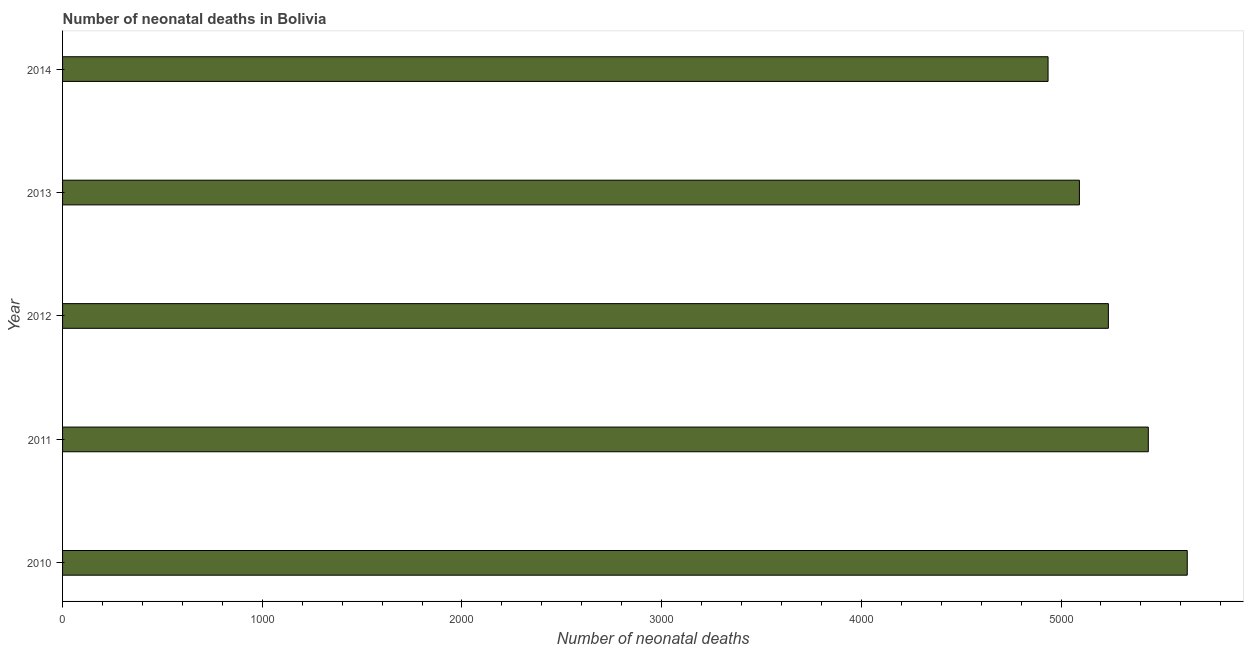Does the graph contain any zero values?
Ensure brevity in your answer.  No. What is the title of the graph?
Provide a succinct answer. Number of neonatal deaths in Bolivia. What is the label or title of the X-axis?
Offer a terse response. Number of neonatal deaths. What is the label or title of the Y-axis?
Make the answer very short. Year. What is the number of neonatal deaths in 2011?
Keep it short and to the point. 5437. Across all years, what is the maximum number of neonatal deaths?
Give a very brief answer. 5632. Across all years, what is the minimum number of neonatal deaths?
Offer a terse response. 4935. In which year was the number of neonatal deaths maximum?
Keep it short and to the point. 2010. In which year was the number of neonatal deaths minimum?
Ensure brevity in your answer.  2014. What is the sum of the number of neonatal deaths?
Provide a succinct answer. 2.63e+04. What is the difference between the number of neonatal deaths in 2013 and 2014?
Offer a very short reply. 157. What is the average number of neonatal deaths per year?
Make the answer very short. 5266. What is the median number of neonatal deaths?
Your answer should be very brief. 5237. What is the ratio of the number of neonatal deaths in 2010 to that in 2012?
Ensure brevity in your answer.  1.07. Is the difference between the number of neonatal deaths in 2013 and 2014 greater than the difference between any two years?
Your answer should be compact. No. What is the difference between the highest and the second highest number of neonatal deaths?
Provide a short and direct response. 195. Is the sum of the number of neonatal deaths in 2012 and 2014 greater than the maximum number of neonatal deaths across all years?
Provide a succinct answer. Yes. What is the difference between the highest and the lowest number of neonatal deaths?
Keep it short and to the point. 697. How many years are there in the graph?
Your answer should be very brief. 5. Are the values on the major ticks of X-axis written in scientific E-notation?
Make the answer very short. No. What is the Number of neonatal deaths in 2010?
Provide a succinct answer. 5632. What is the Number of neonatal deaths in 2011?
Provide a succinct answer. 5437. What is the Number of neonatal deaths in 2012?
Offer a very short reply. 5237. What is the Number of neonatal deaths in 2013?
Offer a terse response. 5092. What is the Number of neonatal deaths in 2014?
Provide a succinct answer. 4935. What is the difference between the Number of neonatal deaths in 2010 and 2011?
Ensure brevity in your answer.  195. What is the difference between the Number of neonatal deaths in 2010 and 2012?
Provide a succinct answer. 395. What is the difference between the Number of neonatal deaths in 2010 and 2013?
Give a very brief answer. 540. What is the difference between the Number of neonatal deaths in 2010 and 2014?
Offer a very short reply. 697. What is the difference between the Number of neonatal deaths in 2011 and 2012?
Offer a very short reply. 200. What is the difference between the Number of neonatal deaths in 2011 and 2013?
Make the answer very short. 345. What is the difference between the Number of neonatal deaths in 2011 and 2014?
Provide a succinct answer. 502. What is the difference between the Number of neonatal deaths in 2012 and 2013?
Your response must be concise. 145. What is the difference between the Number of neonatal deaths in 2012 and 2014?
Keep it short and to the point. 302. What is the difference between the Number of neonatal deaths in 2013 and 2014?
Keep it short and to the point. 157. What is the ratio of the Number of neonatal deaths in 2010 to that in 2011?
Your answer should be compact. 1.04. What is the ratio of the Number of neonatal deaths in 2010 to that in 2012?
Your answer should be compact. 1.07. What is the ratio of the Number of neonatal deaths in 2010 to that in 2013?
Your answer should be very brief. 1.11. What is the ratio of the Number of neonatal deaths in 2010 to that in 2014?
Your answer should be compact. 1.14. What is the ratio of the Number of neonatal deaths in 2011 to that in 2012?
Make the answer very short. 1.04. What is the ratio of the Number of neonatal deaths in 2011 to that in 2013?
Give a very brief answer. 1.07. What is the ratio of the Number of neonatal deaths in 2011 to that in 2014?
Offer a terse response. 1.1. What is the ratio of the Number of neonatal deaths in 2012 to that in 2013?
Ensure brevity in your answer.  1.03. What is the ratio of the Number of neonatal deaths in 2012 to that in 2014?
Your response must be concise. 1.06. What is the ratio of the Number of neonatal deaths in 2013 to that in 2014?
Offer a very short reply. 1.03. 